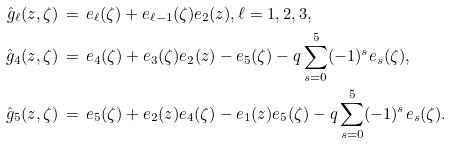<formula> <loc_0><loc_0><loc_500><loc_500>\hat { g } _ { \ell } ( z , \zeta ) & \, = \, e _ { \ell } ( \zeta ) + e _ { \ell - 1 } ( \zeta ) e _ { 2 } ( z ) , \ell = 1 , 2 , 3 , \\ \hat { g } _ { 4 } ( z , \zeta ) & \, = \, e _ { 4 } ( \zeta ) + e _ { 3 } ( \zeta ) e _ { 2 } ( z ) - e _ { 5 } ( \zeta ) - q \sum _ { s = 0 } ^ { 5 } ( - 1 ) ^ { s } e _ { s } ( \zeta ) , \\ \hat { g } _ { 5 } ( z , \zeta ) & \, = \, e _ { 5 } ( \zeta ) + e _ { 2 } ( z ) e _ { 4 } ( \zeta ) - e _ { 1 } ( z ) e _ { 5 } ( \zeta ) - q \sum _ { s = 0 } ^ { 5 } ( - 1 ) ^ { s } e _ { s } ( \zeta ) .</formula> 